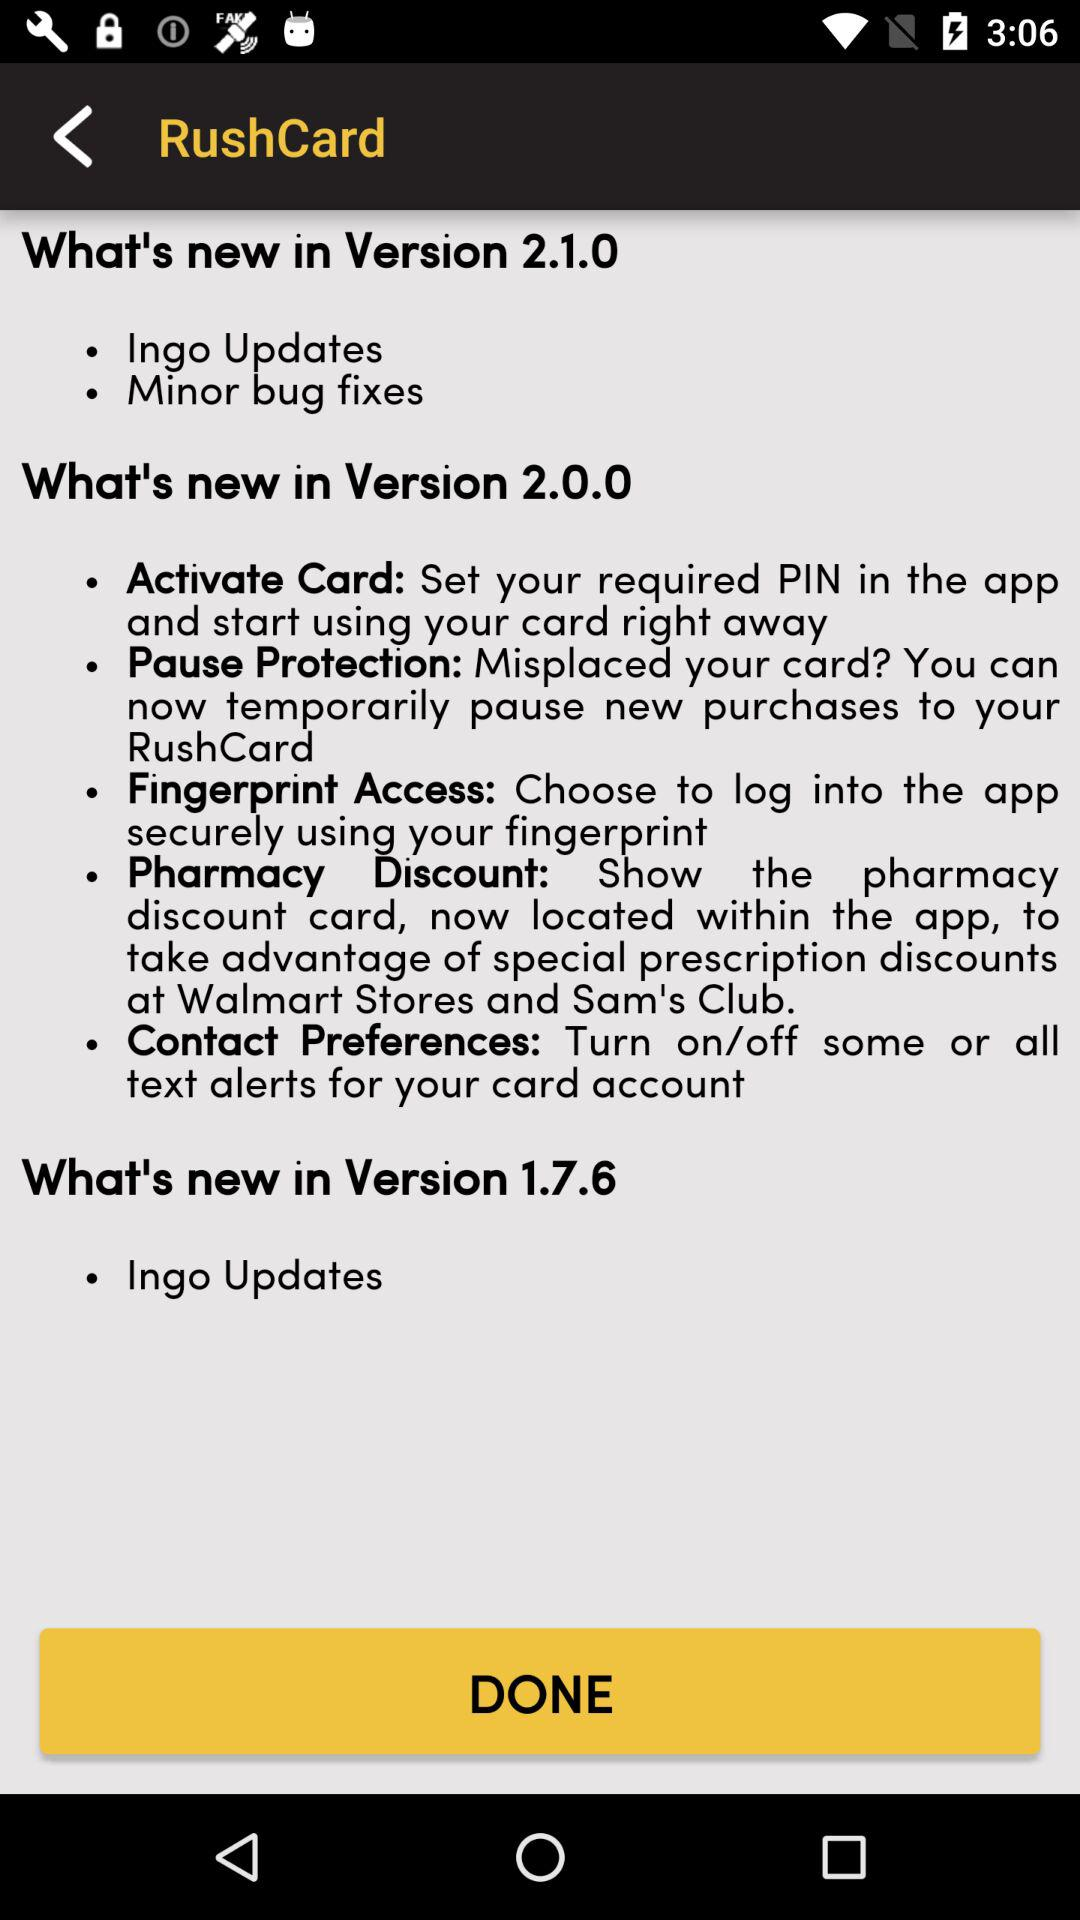In which version do we get a pharmacy discount? You get a pharmacy discount in version 2.0.0. 